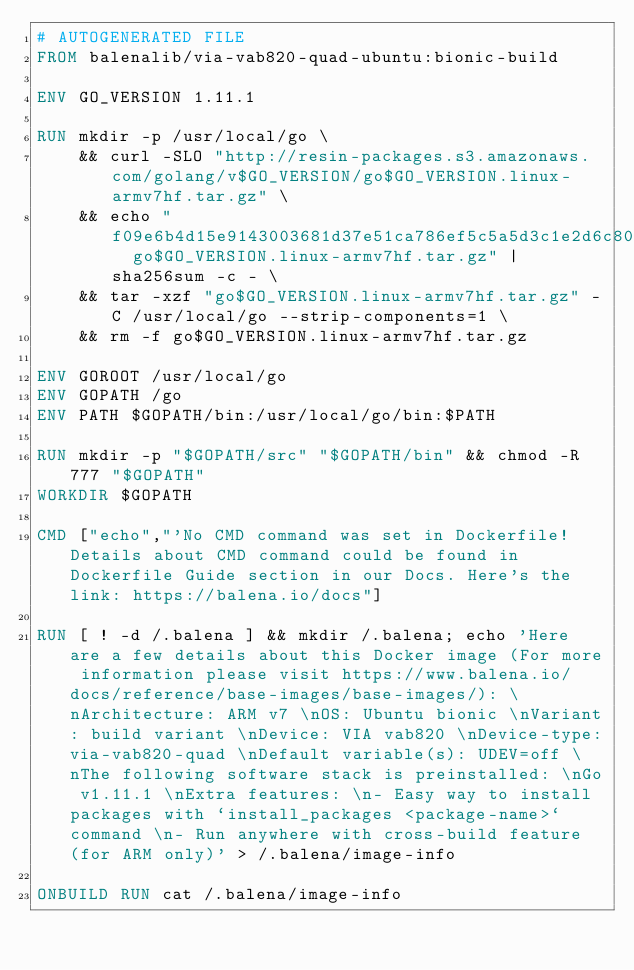<code> <loc_0><loc_0><loc_500><loc_500><_Dockerfile_># AUTOGENERATED FILE
FROM balenalib/via-vab820-quad-ubuntu:bionic-build

ENV GO_VERSION 1.11.1

RUN mkdir -p /usr/local/go \
	&& curl -SLO "http://resin-packages.s3.amazonaws.com/golang/v$GO_VERSION/go$GO_VERSION.linux-armv7hf.tar.gz" \
	&& echo "f09e6b4d15e9143003681d37e51ca786ef5c5a5d3c1e2d6c8073e61c823b8c1a  go$GO_VERSION.linux-armv7hf.tar.gz" | sha256sum -c - \
	&& tar -xzf "go$GO_VERSION.linux-armv7hf.tar.gz" -C /usr/local/go --strip-components=1 \
	&& rm -f go$GO_VERSION.linux-armv7hf.tar.gz

ENV GOROOT /usr/local/go
ENV GOPATH /go
ENV PATH $GOPATH/bin:/usr/local/go/bin:$PATH

RUN mkdir -p "$GOPATH/src" "$GOPATH/bin" && chmod -R 777 "$GOPATH"
WORKDIR $GOPATH

CMD ["echo","'No CMD command was set in Dockerfile! Details about CMD command could be found in Dockerfile Guide section in our Docs. Here's the link: https://balena.io/docs"]

RUN [ ! -d /.balena ] && mkdir /.balena; echo 'Here are a few details about this Docker image (For more information please visit https://www.balena.io/docs/reference/base-images/base-images/): \nArchitecture: ARM v7 \nOS: Ubuntu bionic \nVariant: build variant \nDevice: VIA vab820 \nDevice-type:via-vab820-quad \nDefault variable(s): UDEV=off \nThe following software stack is preinstalled: \nGo v1.11.1 \nExtra features: \n- Easy way to install packages with `install_packages <package-name>` command \n- Run anywhere with cross-build feature  (for ARM only)' > /.balena/image-info

ONBUILD RUN cat /.balena/image-info</code> 